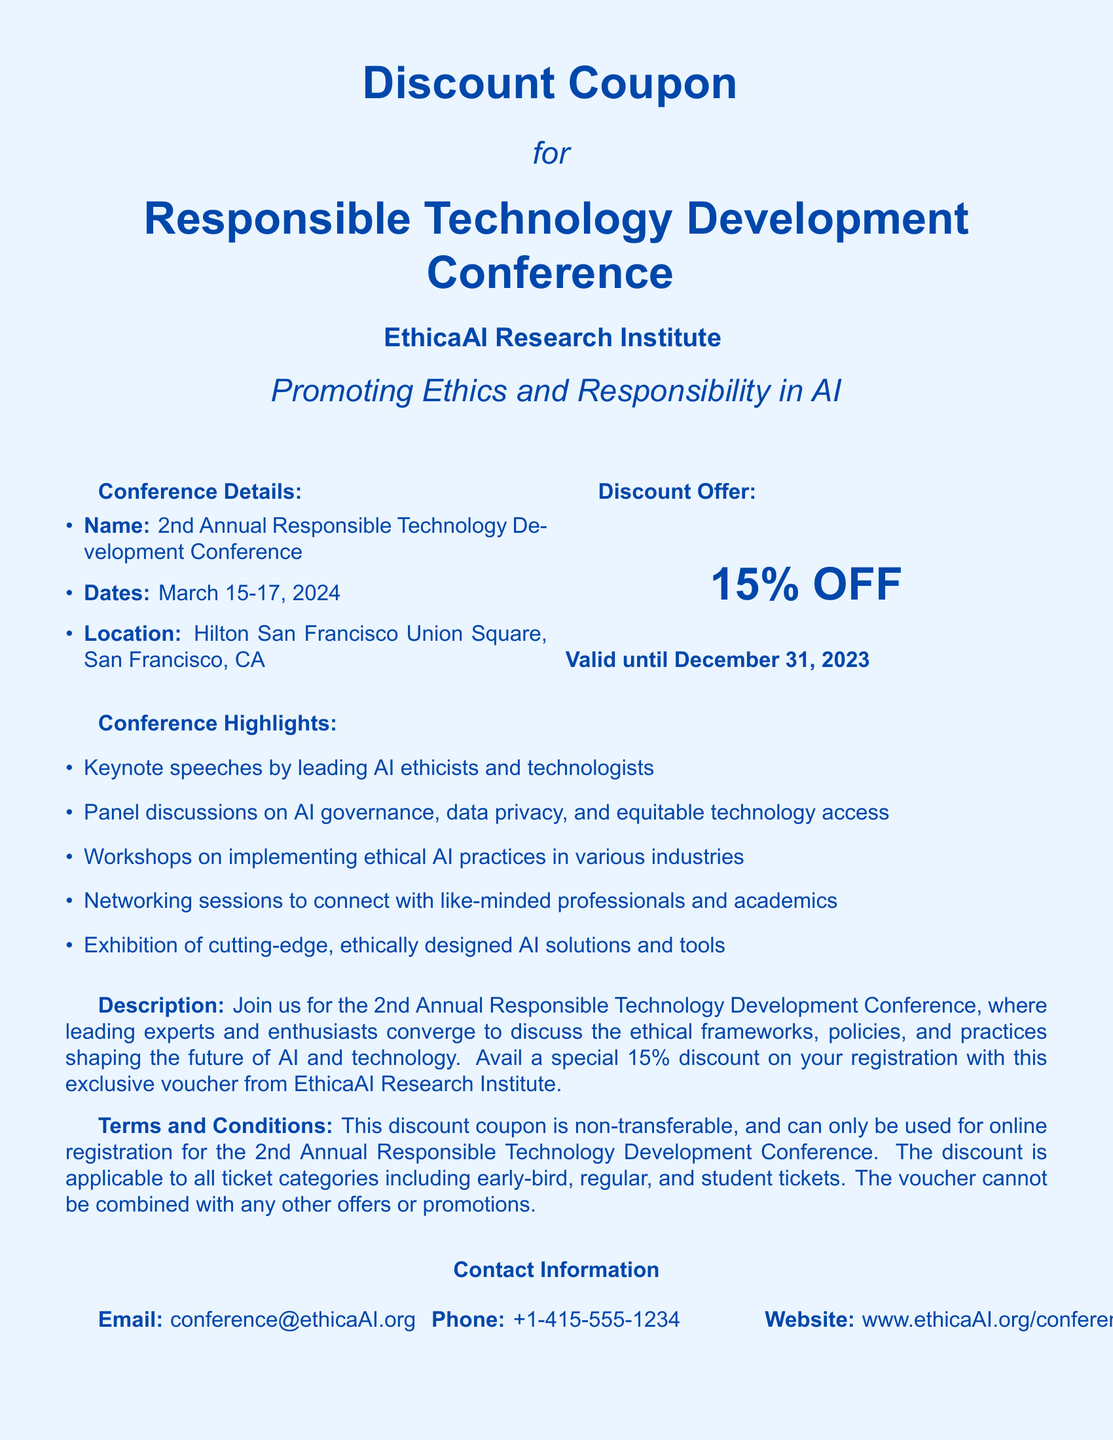What is the name of the conference? The conference is titled "2nd Annual Responsible Technology Development Conference."
Answer: 2nd Annual Responsible Technology Development Conference What are the dates of the conference? The document states that the conference will take place from March 15-17, 2024.
Answer: March 15-17, 2024 What is the discount offered? The document specifies a "15% OFF" discount on registrations.
Answer: 15% OFF What is the validity period of the discount? The discount coupon is valid until December 31, 2023, as mentioned in the offer section.
Answer: December 31, 2023 What is the location of the conference? The location of the conference is stated as Hilton San Francisco Union Square, San Francisco, CA.
Answer: Hilton San Francisco Union Square, San Francisco, CA What types of professionals is the conference aimed at? The document highlights connecting with "like-minded professionals and academics," indicating the target audience.
Answer: Like-minded professionals and academics Are other promotions combinable with this discount? The document clearly states that the voucher cannot be combined with any other offers or promotions, indicating exclusivity.
Answer: No What is the contact email provided? The document lists "conference@ethicaAI.org" as the contact email for the conference.
Answer: conference@ethicaAI.org 